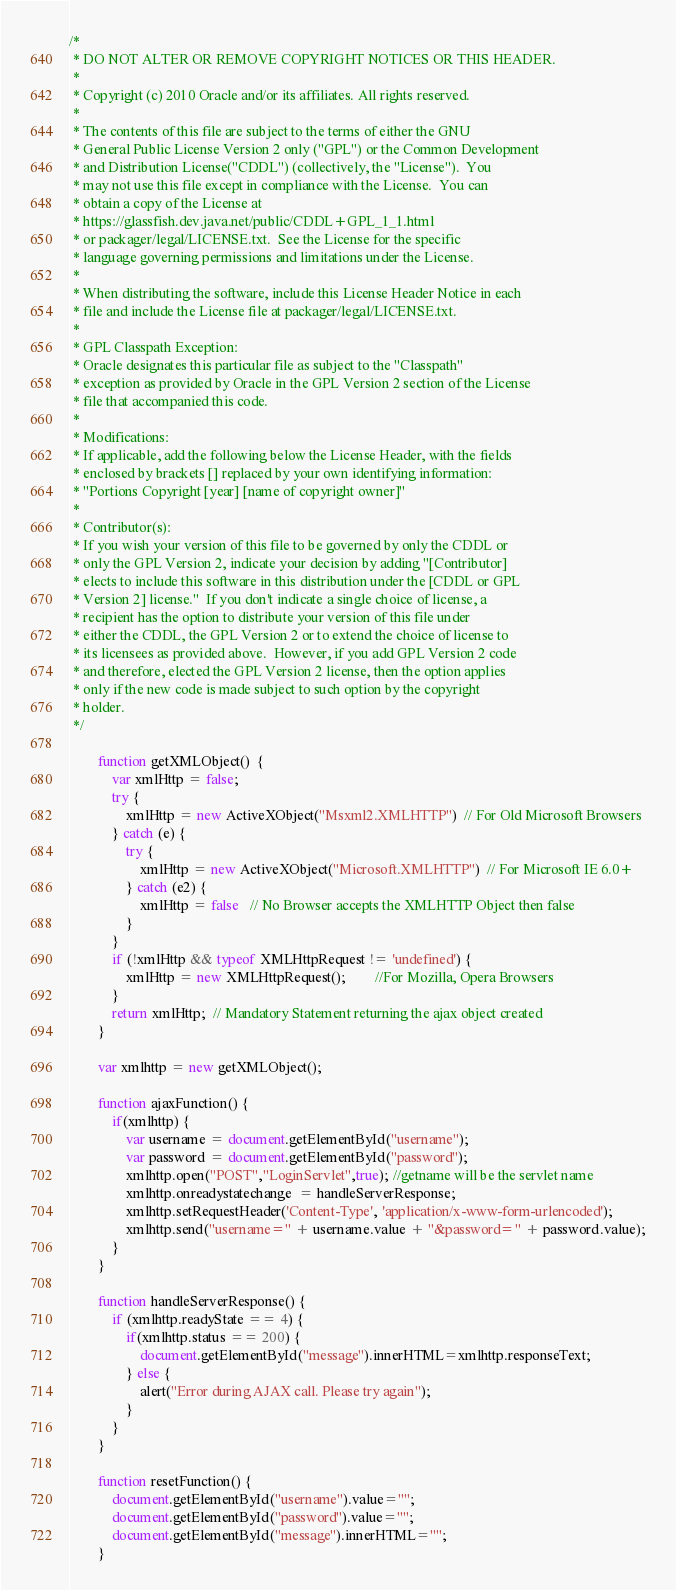<code> <loc_0><loc_0><loc_500><loc_500><_JavaScript_>/*
 * DO NOT ALTER OR REMOVE COPYRIGHT NOTICES OR THIS HEADER.
 *
 * Copyright (c) 2010 Oracle and/or its affiliates. All rights reserved.
 *
 * The contents of this file are subject to the terms of either the GNU
 * General Public License Version 2 only ("GPL") or the Common Development
 * and Distribution License("CDDL") (collectively, the "License").  You
 * may not use this file except in compliance with the License.  You can
 * obtain a copy of the License at
 * https://glassfish.dev.java.net/public/CDDL+GPL_1_1.html
 * or packager/legal/LICENSE.txt.  See the License for the specific
 * language governing permissions and limitations under the License.
 *
 * When distributing the software, include this License Header Notice in each
 * file and include the License file at packager/legal/LICENSE.txt.
 *
 * GPL Classpath Exception:
 * Oracle designates this particular file as subject to the "Classpath"
 * exception as provided by Oracle in the GPL Version 2 section of the License
 * file that accompanied this code.
 *
 * Modifications:
 * If applicable, add the following below the License Header, with the fields
 * enclosed by brackets [] replaced by your own identifying information:
 * "Portions Copyright [year] [name of copyright owner]"
 *
 * Contributor(s):
 * If you wish your version of this file to be governed by only the CDDL or
 * only the GPL Version 2, indicate your decision by adding "[Contributor]
 * elects to include this software in this distribution under the [CDDL or GPL
 * Version 2] license."  If you don't indicate a single choice of license, a
 * recipient has the option to distribute your version of this file under
 * either the CDDL, the GPL Version 2 or to extend the choice of license to
 * its licensees as provided above.  However, if you add GPL Version 2 code
 * and therefore, elected the GPL Version 2 license, then the option applies
 * only if the new code is made subject to such option by the copyright
 * holder.
 */

        function getXMLObject()  {
            var xmlHttp = false;
            try {
                xmlHttp = new ActiveXObject("Msxml2.XMLHTTP")  // For Old Microsoft Browsers
            } catch (e) {
                try {
                    xmlHttp = new ActiveXObject("Microsoft.XMLHTTP")  // For Microsoft IE 6.0+
                } catch (e2) {
                    xmlHttp = false   // No Browser accepts the XMLHTTP Object then false
                }
            }
            if (!xmlHttp && typeof XMLHttpRequest != 'undefined') {
                xmlHttp = new XMLHttpRequest();        //For Mozilla, Opera Browsers
            }
            return xmlHttp;  // Mandatory Statement returning the ajax object created
        }

        var xmlhttp = new getXMLObject();

        function ajaxFunction() {
            if(xmlhttp) {
                var username = document.getElementById("username");
                var password = document.getElementById("password");
                xmlhttp.open("POST","LoginServlet",true); //getname will be the servlet name
                xmlhttp.onreadystatechange  = handleServerResponse;
                xmlhttp.setRequestHeader('Content-Type', 'application/x-www-form-urlencoded');
                xmlhttp.send("username=" + username.value + "&password=" + password.value);
            }
        }

        function handleServerResponse() {
            if (xmlhttp.readyState == 4) {
                if(xmlhttp.status == 200) {
                    document.getElementById("message").innerHTML=xmlhttp.responseText; 
                } else {
                    alert("Error during AJAX call. Please try again");
                }
            }
        }

        function resetFunction() {
            document.getElementById("username").value="";
            document.getElementById("password").value="";
            document.getElementById("message").innerHTML="";
        }

</code> 